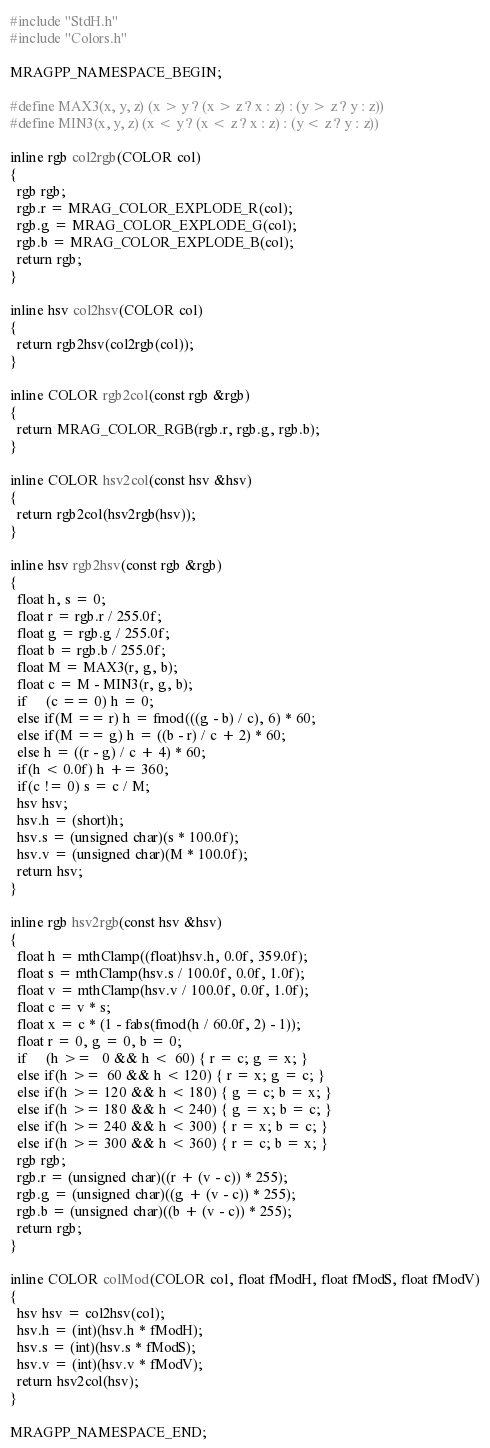<code> <loc_0><loc_0><loc_500><loc_500><_C++_>#include "StdH.h"
#include "Colors.h"

MRAGPP_NAMESPACE_BEGIN;

#define MAX3(x, y, z) (x > y ? (x > z ? x : z) : (y > z ? y : z))
#define MIN3(x, y, z) (x < y ? (x < z ? x : z) : (y < z ? y : z))

inline rgb col2rgb(COLOR col)
{
  rgb rgb;
  rgb.r = MRAG_COLOR_EXPLODE_R(col);
  rgb.g = MRAG_COLOR_EXPLODE_G(col);
  rgb.b = MRAG_COLOR_EXPLODE_B(col);
  return rgb;
}

inline hsv col2hsv(COLOR col)
{
  return rgb2hsv(col2rgb(col));
}

inline COLOR rgb2col(const rgb &rgb)
{
  return MRAG_COLOR_RGB(rgb.r, rgb.g, rgb.b);
}

inline COLOR hsv2col(const hsv &hsv)
{
  return rgb2col(hsv2rgb(hsv));
}

inline hsv rgb2hsv(const rgb &rgb)
{
  float h, s = 0;
  float r = rgb.r / 255.0f;
  float g = rgb.g / 255.0f;
  float b = rgb.b / 255.0f;
  float M = MAX3(r, g, b);
  float c = M - MIN3(r, g, b);
  if     (c == 0) h = 0;
  else if(M == r) h = fmod(((g - b) / c), 6) * 60;
  else if(M == g) h = ((b - r) / c + 2) * 60;
  else h = ((r - g) / c + 4) * 60;
  if(h < 0.0f) h += 360;
  if(c != 0) s = c / M;
  hsv hsv;
  hsv.h = (short)h;
  hsv.s = (unsigned char)(s * 100.0f);
  hsv.v = (unsigned char)(M * 100.0f);
  return hsv;
}

inline rgb hsv2rgb(const hsv &hsv)
{
  float h = mthClamp((float)hsv.h, 0.0f, 359.0f);
  float s = mthClamp(hsv.s / 100.0f, 0.0f, 1.0f);
  float v = mthClamp(hsv.v / 100.0f, 0.0f, 1.0f);
  float c = v * s;
  float x = c * (1 - fabs(fmod(h / 60.0f, 2) - 1));
  float r = 0, g = 0, b = 0;
  if     (h >=   0 && h <  60) { r = c; g = x; }
  else if(h >=  60 && h < 120) { r = x; g = c; }
  else if(h >= 120 && h < 180) { g = c; b = x; }
  else if(h >= 180 && h < 240) { g = x; b = c; }
  else if(h >= 240 && h < 300) { r = x; b = c; }
  else if(h >= 300 && h < 360) { r = c; b = x; }
  rgb rgb;
  rgb.r = (unsigned char)((r + (v - c)) * 255);
  rgb.g = (unsigned char)((g + (v - c)) * 255);
  rgb.b = (unsigned char)((b + (v - c)) * 255);
  return rgb;
}

inline COLOR colMod(COLOR col, float fModH, float fModS, float fModV)
{
  hsv hsv = col2hsv(col);
  hsv.h = (int)(hsv.h * fModH);
  hsv.s = (int)(hsv.s * fModS);
  hsv.v = (int)(hsv.v * fModV);
  return hsv2col(hsv);
}

MRAGPP_NAMESPACE_END;
</code> 